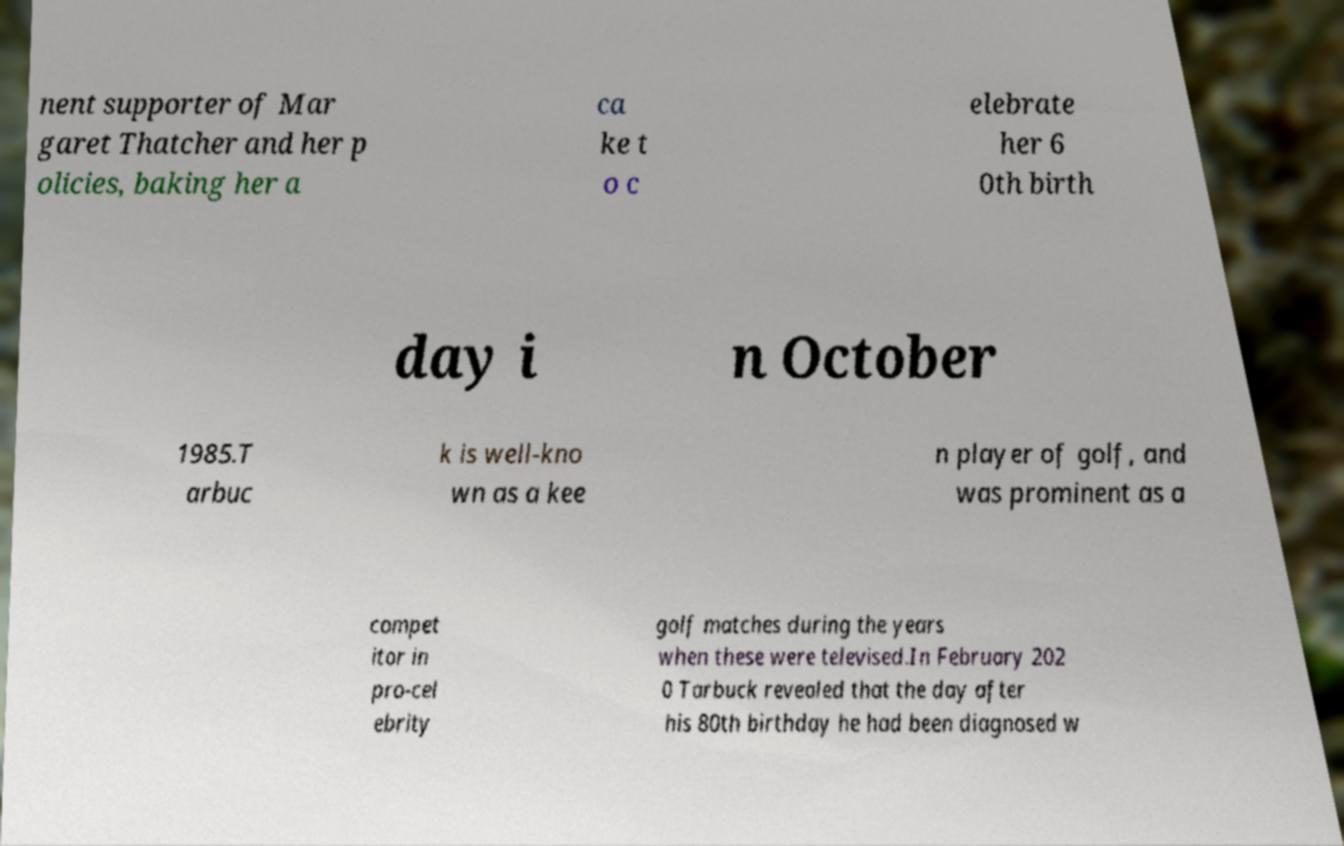Can you accurately transcribe the text from the provided image for me? nent supporter of Mar garet Thatcher and her p olicies, baking her a ca ke t o c elebrate her 6 0th birth day i n October 1985.T arbuc k is well-kno wn as a kee n player of golf, and was prominent as a compet itor in pro-cel ebrity golf matches during the years when these were televised.In February 202 0 Tarbuck revealed that the day after his 80th birthday he had been diagnosed w 